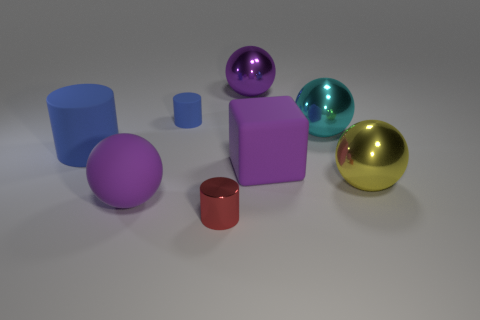Subtract all blue cylinders. How many were subtracted if there are1blue cylinders left? 1 Subtract all small metallic cylinders. How many cylinders are left? 2 Subtract all green balls. How many blue cylinders are left? 2 Subtract all blue cylinders. How many cylinders are left? 1 Subtract all blocks. How many objects are left? 7 Add 2 red metal objects. How many objects exist? 10 Subtract 1 cylinders. How many cylinders are left? 2 Subtract 0 gray balls. How many objects are left? 8 Subtract all green balls. Subtract all gray blocks. How many balls are left? 4 Subtract all large yellow objects. Subtract all cylinders. How many objects are left? 4 